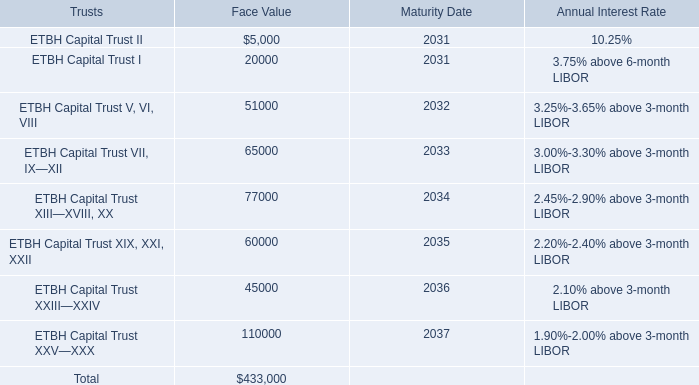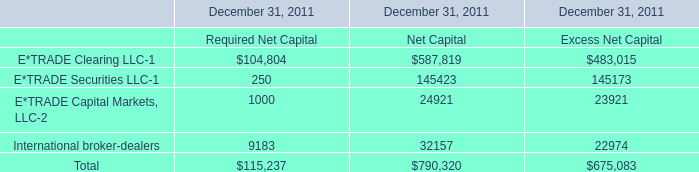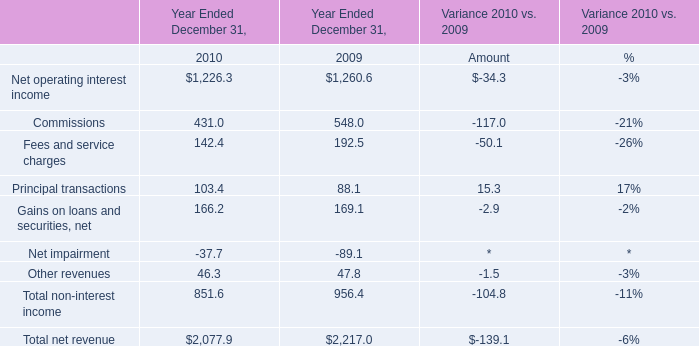what's the total amount of E*TRADE Capital Markets, LLC of December 31, 2011 Net Capital, ETBH Capital Trust I of Maturity Date, and ETBH Capital Trust XIX, XXI, XXII of Face Value ? 
Computations: ((24921.0 + 2031.0) + 60000.0)
Answer: 86952.0. 